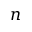Convert formula to latex. <formula><loc_0><loc_0><loc_500><loc_500>n</formula> 